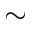<formula> <loc_0><loc_0><loc_500><loc_500>\sim</formula> 